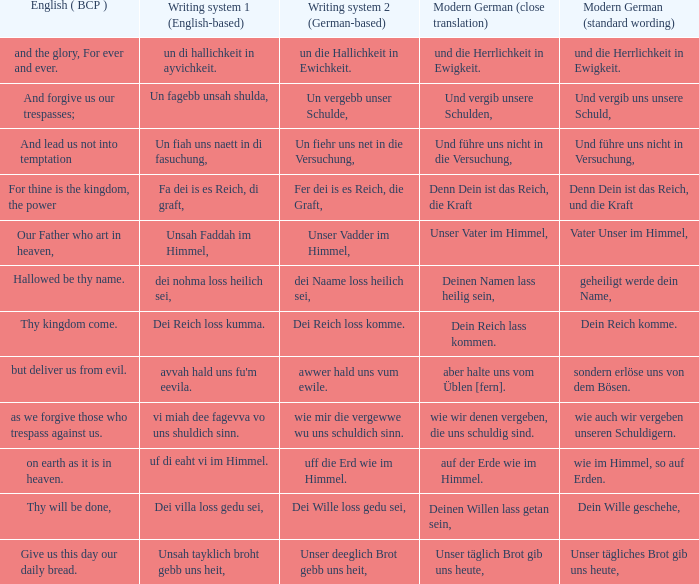What is the english (bcp) phrase "for thine is the kingdom, the power" in modern german with standard wording? Denn Dein ist das Reich, und die Kraft. 